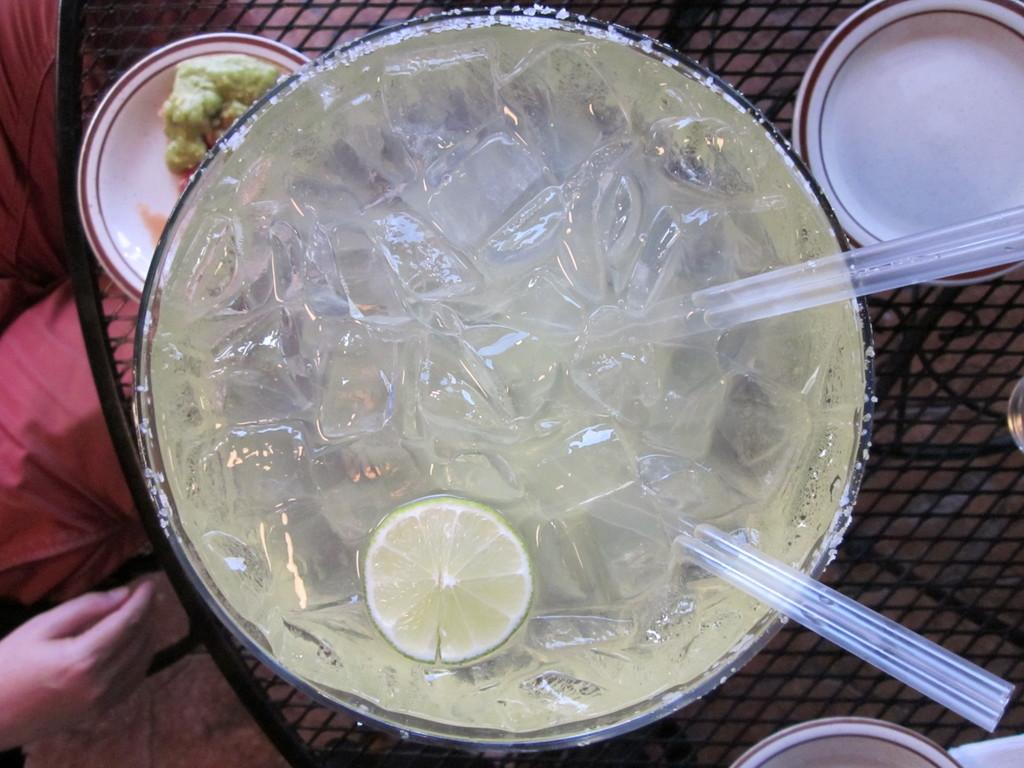What is in the glass that is visible in the image? There is a glass with ice cubes, lemon, and straws in the image. What other items can be seen in the image? There are plates visible in the image. What is the color of the surface on which the objects are placed? The objects are on a black color surface. Can you describe the person in the image? There is a person on the left side of the image. What type of crayon can be seen on the person's hand in the image? There is no crayon present in the image. 